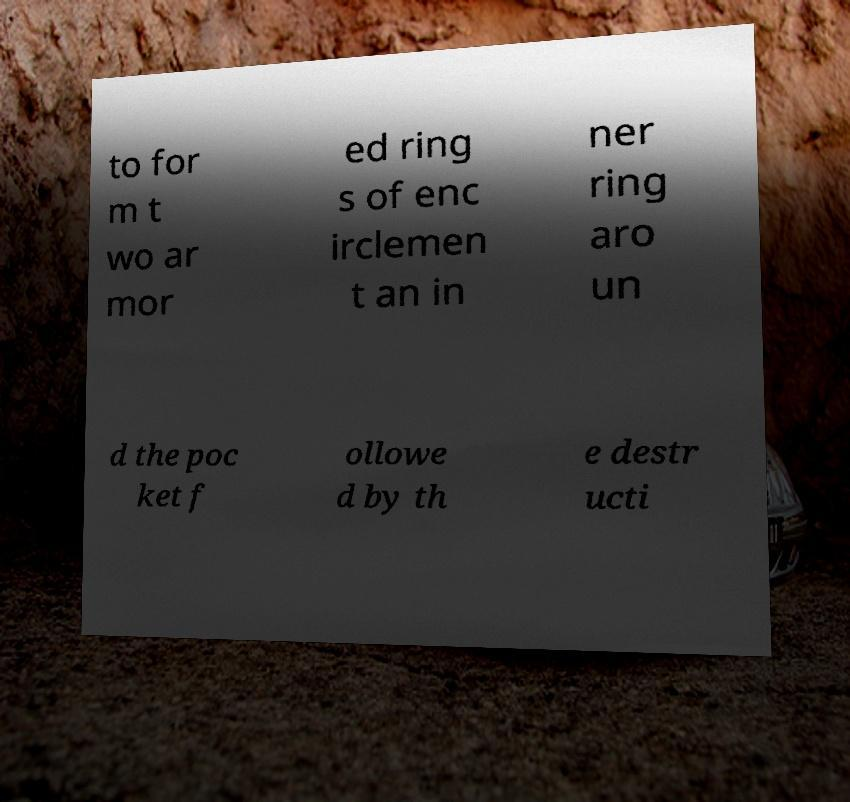For documentation purposes, I need the text within this image transcribed. Could you provide that? to for m t wo ar mor ed ring s of enc irclemen t an in ner ring aro un d the poc ket f ollowe d by th e destr ucti 